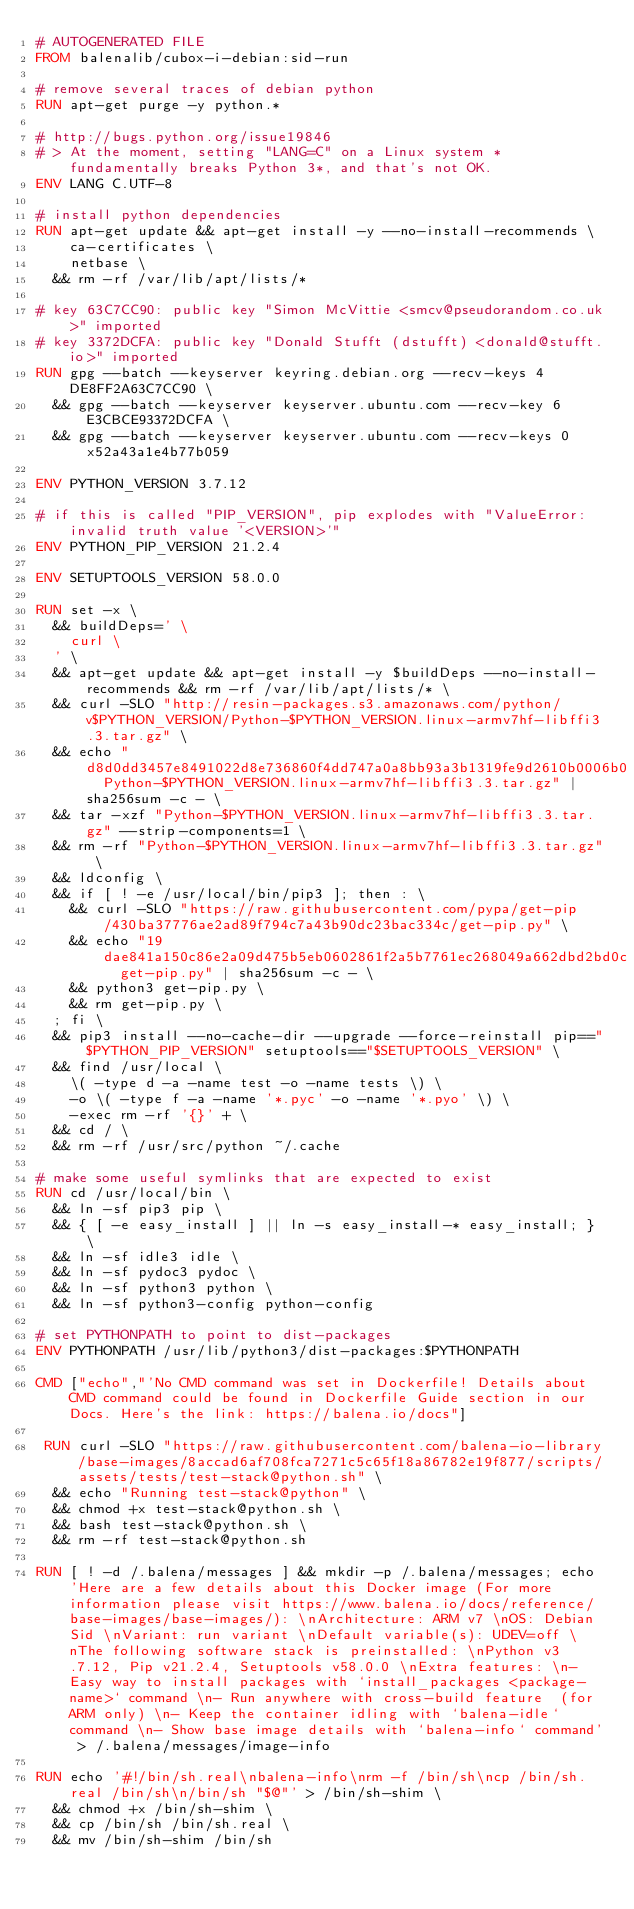Convert code to text. <code><loc_0><loc_0><loc_500><loc_500><_Dockerfile_># AUTOGENERATED FILE
FROM balenalib/cubox-i-debian:sid-run

# remove several traces of debian python
RUN apt-get purge -y python.*

# http://bugs.python.org/issue19846
# > At the moment, setting "LANG=C" on a Linux system *fundamentally breaks Python 3*, and that's not OK.
ENV LANG C.UTF-8

# install python dependencies
RUN apt-get update && apt-get install -y --no-install-recommends \
		ca-certificates \
		netbase \
	&& rm -rf /var/lib/apt/lists/*

# key 63C7CC90: public key "Simon McVittie <smcv@pseudorandom.co.uk>" imported
# key 3372DCFA: public key "Donald Stufft (dstufft) <donald@stufft.io>" imported
RUN gpg --batch --keyserver keyring.debian.org --recv-keys 4DE8FF2A63C7CC90 \
	&& gpg --batch --keyserver keyserver.ubuntu.com --recv-key 6E3CBCE93372DCFA \
	&& gpg --batch --keyserver keyserver.ubuntu.com --recv-keys 0x52a43a1e4b77b059

ENV PYTHON_VERSION 3.7.12

# if this is called "PIP_VERSION", pip explodes with "ValueError: invalid truth value '<VERSION>'"
ENV PYTHON_PIP_VERSION 21.2.4

ENV SETUPTOOLS_VERSION 58.0.0

RUN set -x \
	&& buildDeps=' \
		curl \
	' \
	&& apt-get update && apt-get install -y $buildDeps --no-install-recommends && rm -rf /var/lib/apt/lists/* \
	&& curl -SLO "http://resin-packages.s3.amazonaws.com/python/v$PYTHON_VERSION/Python-$PYTHON_VERSION.linux-armv7hf-libffi3.3.tar.gz" \
	&& echo "d8d0dd3457e8491022d8e736860f4dd747a0a8bb93a3b1319fe9d2610b0006b0  Python-$PYTHON_VERSION.linux-armv7hf-libffi3.3.tar.gz" | sha256sum -c - \
	&& tar -xzf "Python-$PYTHON_VERSION.linux-armv7hf-libffi3.3.tar.gz" --strip-components=1 \
	&& rm -rf "Python-$PYTHON_VERSION.linux-armv7hf-libffi3.3.tar.gz" \
	&& ldconfig \
	&& if [ ! -e /usr/local/bin/pip3 ]; then : \
		&& curl -SLO "https://raw.githubusercontent.com/pypa/get-pip/430ba37776ae2ad89f794c7a43b90dc23bac334c/get-pip.py" \
		&& echo "19dae841a150c86e2a09d475b5eb0602861f2a5b7761ec268049a662dbd2bd0c  get-pip.py" | sha256sum -c - \
		&& python3 get-pip.py \
		&& rm get-pip.py \
	; fi \
	&& pip3 install --no-cache-dir --upgrade --force-reinstall pip=="$PYTHON_PIP_VERSION" setuptools=="$SETUPTOOLS_VERSION" \
	&& find /usr/local \
		\( -type d -a -name test -o -name tests \) \
		-o \( -type f -a -name '*.pyc' -o -name '*.pyo' \) \
		-exec rm -rf '{}' + \
	&& cd / \
	&& rm -rf /usr/src/python ~/.cache

# make some useful symlinks that are expected to exist
RUN cd /usr/local/bin \
	&& ln -sf pip3 pip \
	&& { [ -e easy_install ] || ln -s easy_install-* easy_install; } \
	&& ln -sf idle3 idle \
	&& ln -sf pydoc3 pydoc \
	&& ln -sf python3 python \
	&& ln -sf python3-config python-config

# set PYTHONPATH to point to dist-packages
ENV PYTHONPATH /usr/lib/python3/dist-packages:$PYTHONPATH

CMD ["echo","'No CMD command was set in Dockerfile! Details about CMD command could be found in Dockerfile Guide section in our Docs. Here's the link: https://balena.io/docs"]

 RUN curl -SLO "https://raw.githubusercontent.com/balena-io-library/base-images/8accad6af708fca7271c5c65f18a86782e19f877/scripts/assets/tests/test-stack@python.sh" \
  && echo "Running test-stack@python" \
  && chmod +x test-stack@python.sh \
  && bash test-stack@python.sh \
  && rm -rf test-stack@python.sh 

RUN [ ! -d /.balena/messages ] && mkdir -p /.balena/messages; echo 'Here are a few details about this Docker image (For more information please visit https://www.balena.io/docs/reference/base-images/base-images/): \nArchitecture: ARM v7 \nOS: Debian Sid \nVariant: run variant \nDefault variable(s): UDEV=off \nThe following software stack is preinstalled: \nPython v3.7.12, Pip v21.2.4, Setuptools v58.0.0 \nExtra features: \n- Easy way to install packages with `install_packages <package-name>` command \n- Run anywhere with cross-build feature  (for ARM only) \n- Keep the container idling with `balena-idle` command \n- Show base image details with `balena-info` command' > /.balena/messages/image-info

RUN echo '#!/bin/sh.real\nbalena-info\nrm -f /bin/sh\ncp /bin/sh.real /bin/sh\n/bin/sh "$@"' > /bin/sh-shim \
	&& chmod +x /bin/sh-shim \
	&& cp /bin/sh /bin/sh.real \
	&& mv /bin/sh-shim /bin/sh</code> 